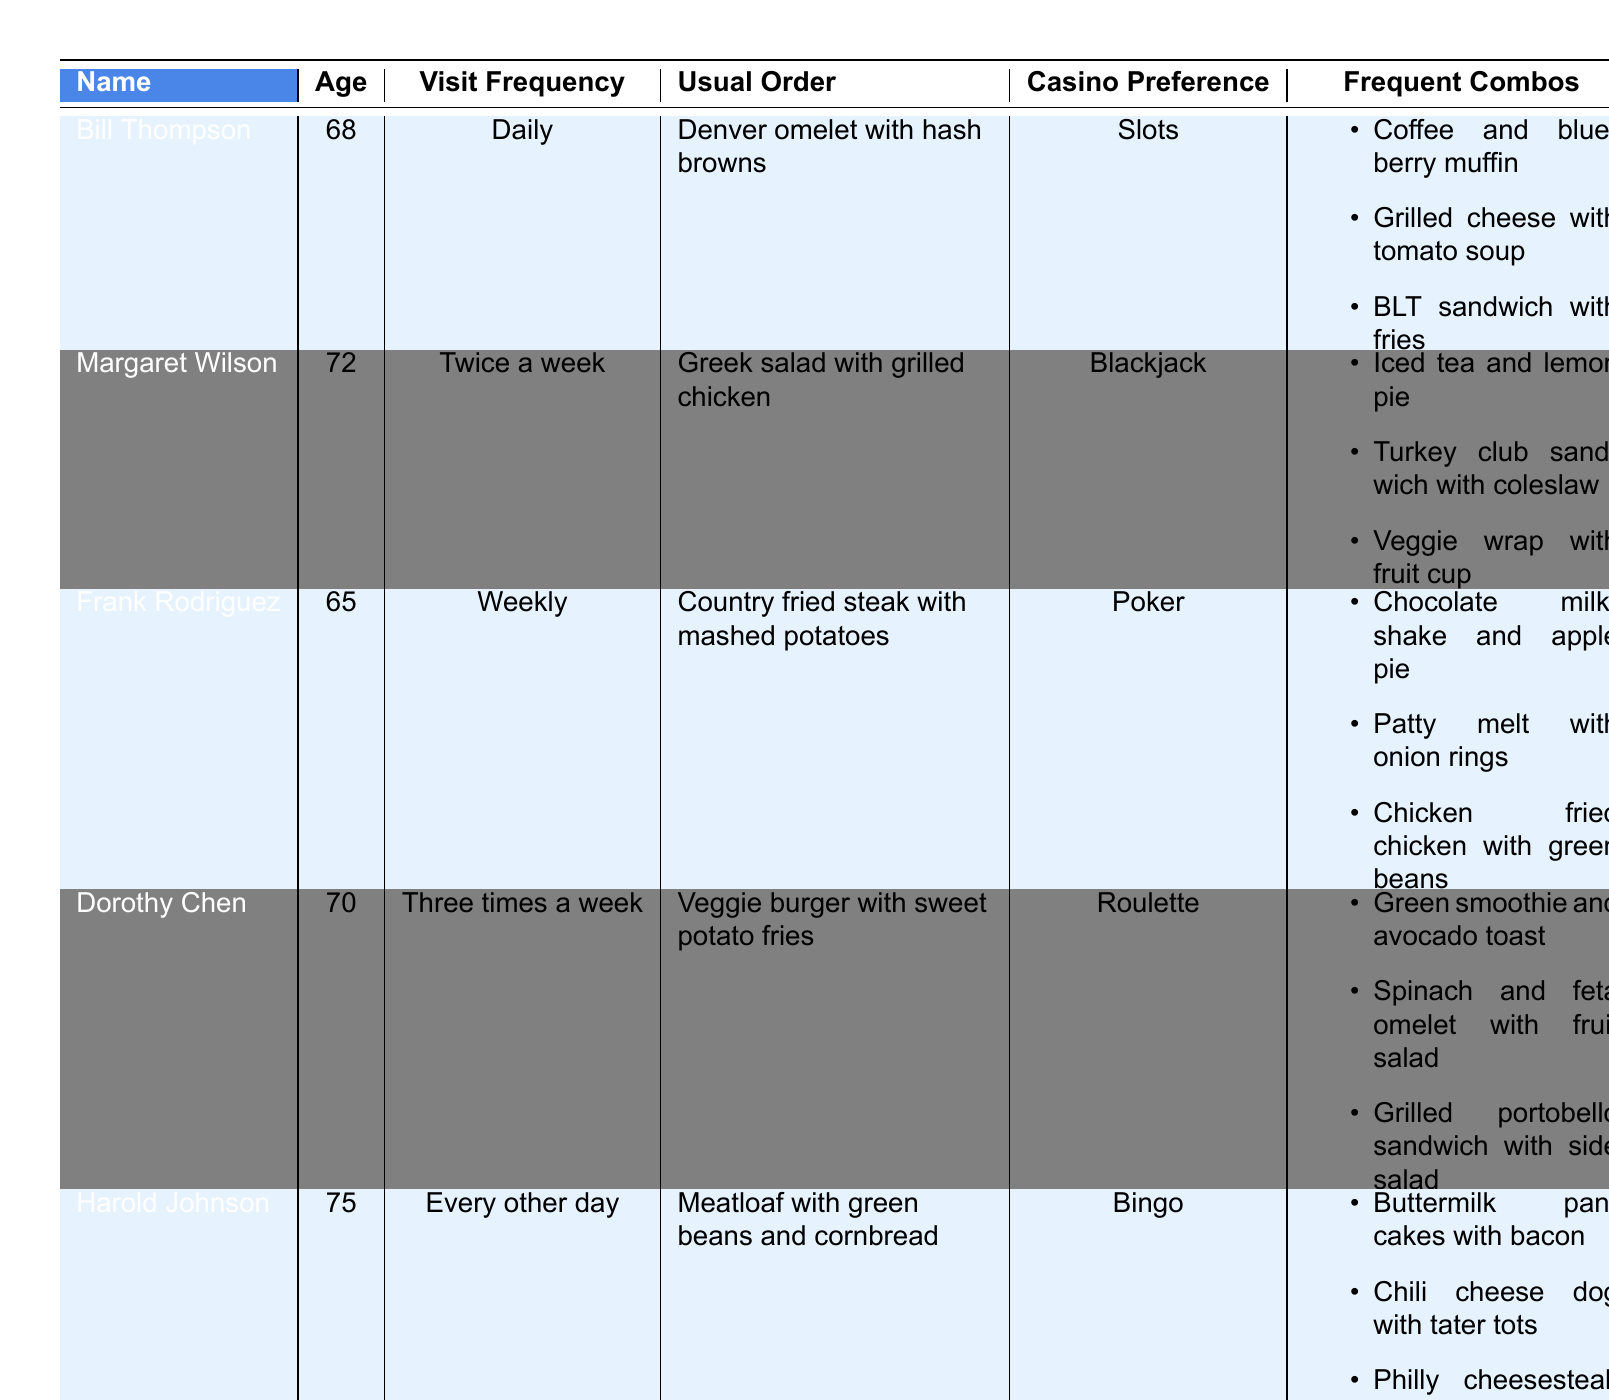What is Bill Thompson’s usual order? From the table, it is explicitly stated in the "Usual Order" column for Bill Thompson that his usual order is a "Denver omelet with hash browns."
Answer: Denver omelet with hash browns Which customer visits the diner daily? By examining the "Visit Frequency" column, we find that Bill Thompson has a visit frequency listed as "Daily."
Answer: Bill Thompson What casino game does Margaret Wilson prefer? The table lists Margaret Wilson's casino preference directly in the "Casino Preference" column as "Blackjack."
Answer: Blackjack How many frequent combos does Frank Rodriguez have? In the "Frequent Combos" section for Frank Rodriguez, there are three items listed: a chocolate milkshake with apple pie, a patty melt with onion rings, and chicken fried chicken with green beans.
Answer: Three Is Harold Johnson’s usual order vegetarian? By checking the "Usual Order" for Harold Johnson, which is "Meatloaf with green beans and cornbread," we can conclude that it is not vegetarian.
Answer: No Which customer has the highest age? The ages listed in the "Age" column show Harold Johnson as the oldest at 75 years old, compared to the others.
Answer: 75 What is the total number of visits per week for Dorothy Chen? Dorothy Chen visits three times a week. To find the total per week, we simply take that value, as the data specifies her frequency is not modified.
Answer: 3 Are the frequent combos for Dorothy Chen entirely vegetarian? Verifying the items in the "Frequent Combos" for Dorothy Chen, we see: green smoothie and avocado toast, spinach and feta omelet, and grilled portobello sandwich. All these items are indeed vegetarian.
Answer: Yes Which customer’s usual order contains meat? By reviewing each "Usual Order," Frank Rodriguez's "Country fried steak with mashed potatoes" and Harold Johnson's "Meatloaf with green beans and cornbread" both contain meat. Frank Rodriguez and Harold Johnson's orders contain meat.
Answer: Frank Rodriguez and Harold Johnson What is the average age of the customers listed? Calculating the average age: (68 + 72 + 65 + 70 + 75) = 350; there are 5 customers, so the average is 350/5 = 70.
Answer: 70 